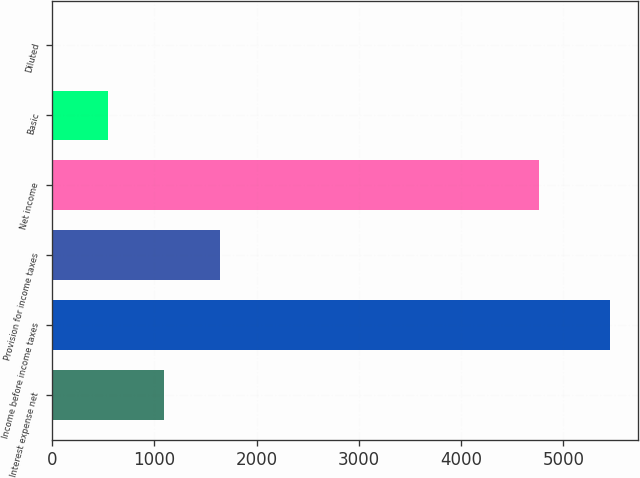Convert chart to OTSL. <chart><loc_0><loc_0><loc_500><loc_500><bar_chart><fcel>Interest expense net<fcel>Income before income taxes<fcel>Provision for income taxes<fcel>Net income<fcel>Basic<fcel>Diluted<nl><fcel>1094.52<fcel>5454<fcel>1639.45<fcel>4760<fcel>549.59<fcel>4.66<nl></chart> 